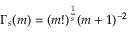<formula> <loc_0><loc_0><loc_500><loc_500>\Gamma _ { s } ( m ) = ( m ! ) ^ { \frac { 1 } { s } } ( m + 1 ) ^ { - 2 }</formula> 